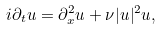<formula> <loc_0><loc_0><loc_500><loc_500>i \partial _ { t } u = \partial _ { x } ^ { 2 } u + \nu | u | ^ { 2 } u ,</formula> 